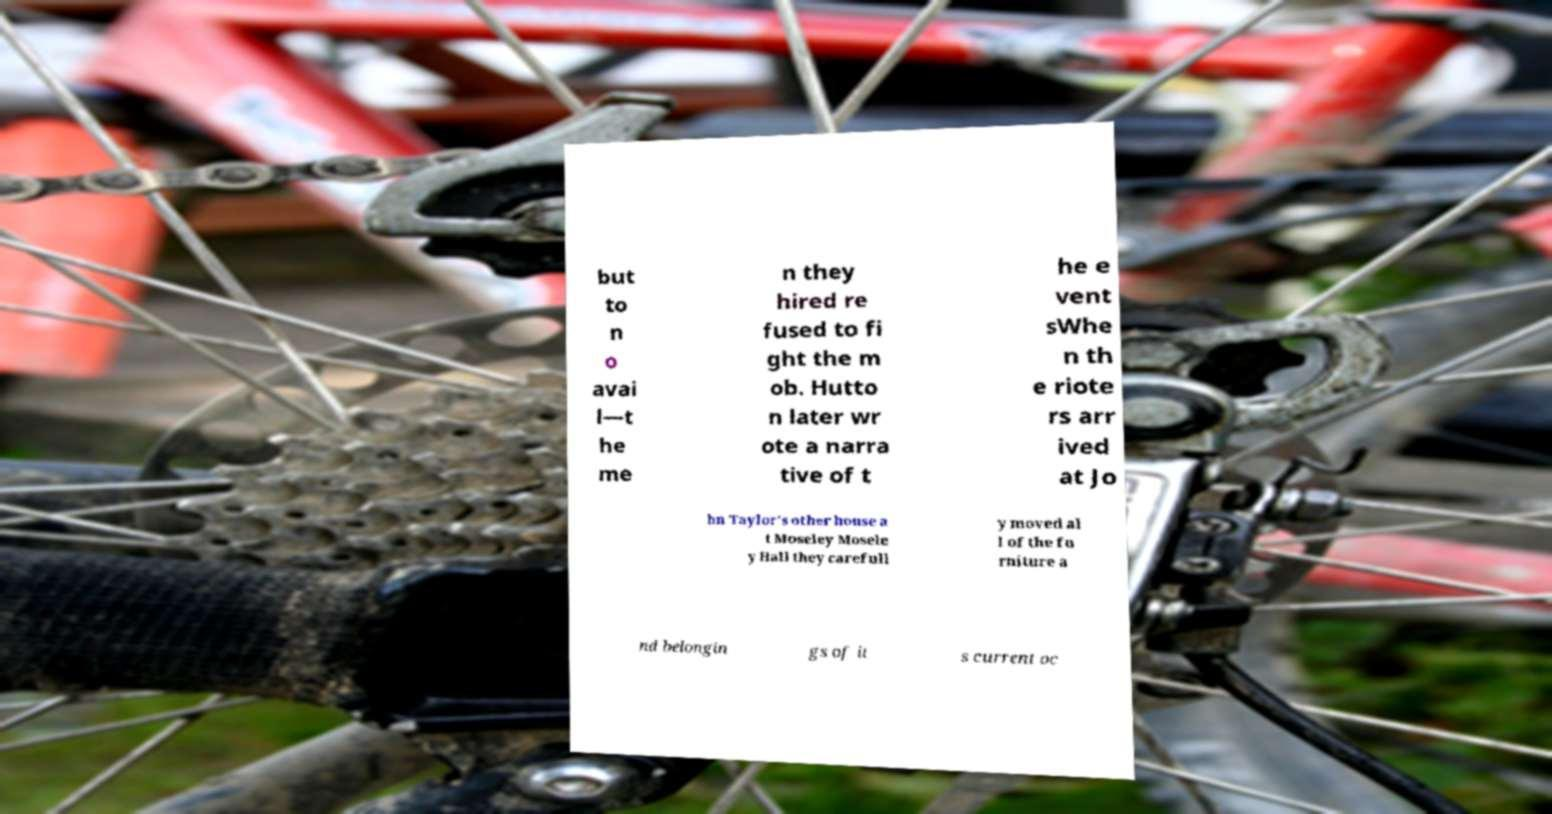I need the written content from this picture converted into text. Can you do that? but to n o avai l—t he me n they hired re fused to fi ght the m ob. Hutto n later wr ote a narra tive of t he e vent sWhe n th e riote rs arr ived at Jo hn Taylor's other house a t Moseley Mosele y Hall they carefull y moved al l of the fu rniture a nd belongin gs of it s current oc 